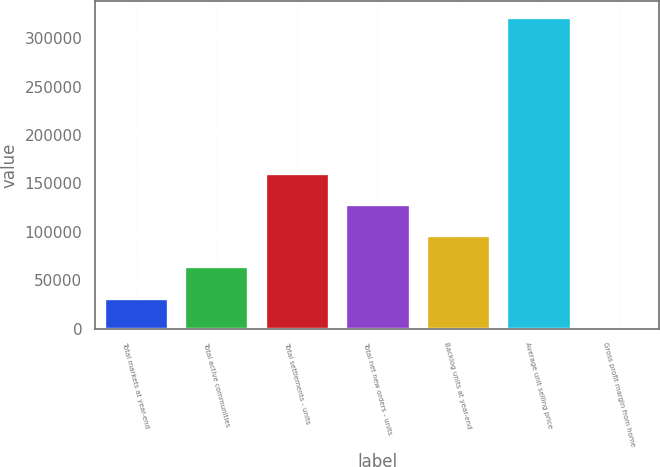Convert chart. <chart><loc_0><loc_0><loc_500><loc_500><bar_chart><fcel>Total markets at year-end<fcel>Total active communities<fcel>Total settlements - units<fcel>Total net new orders - units<fcel>Backlog units at year-end<fcel>Average unit selling price<fcel>Gross profit margin from home<nl><fcel>32204.5<fcel>64404<fcel>161002<fcel>128803<fcel>96603.5<fcel>322000<fcel>5<nl></chart> 